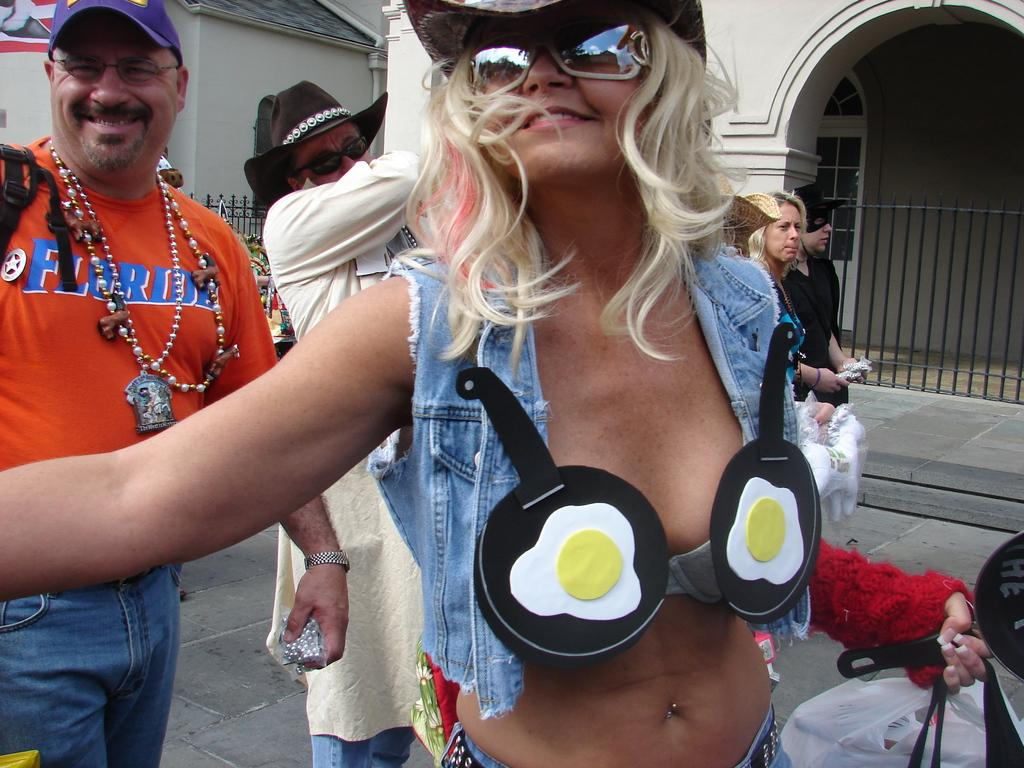How many people are in the image? There are people in the image, but the exact number is not specified. What are the people wearing on their faces? The people are wearing glasses in the image. What type of headwear are the people wearing? The people are wearing hats in the image. What are the people holding in their hands? The people are holding bags in their hands in the image. What can be seen in the distance behind the people? There are buildings in the background of the image. What is at the bottom of the image? There is a road at the bottom of the image. What type of prose is being recited by the people in the image? There is no indication in the image that the people are reciting any prose. How many beans are visible in the image? There are no beans present in the image. 